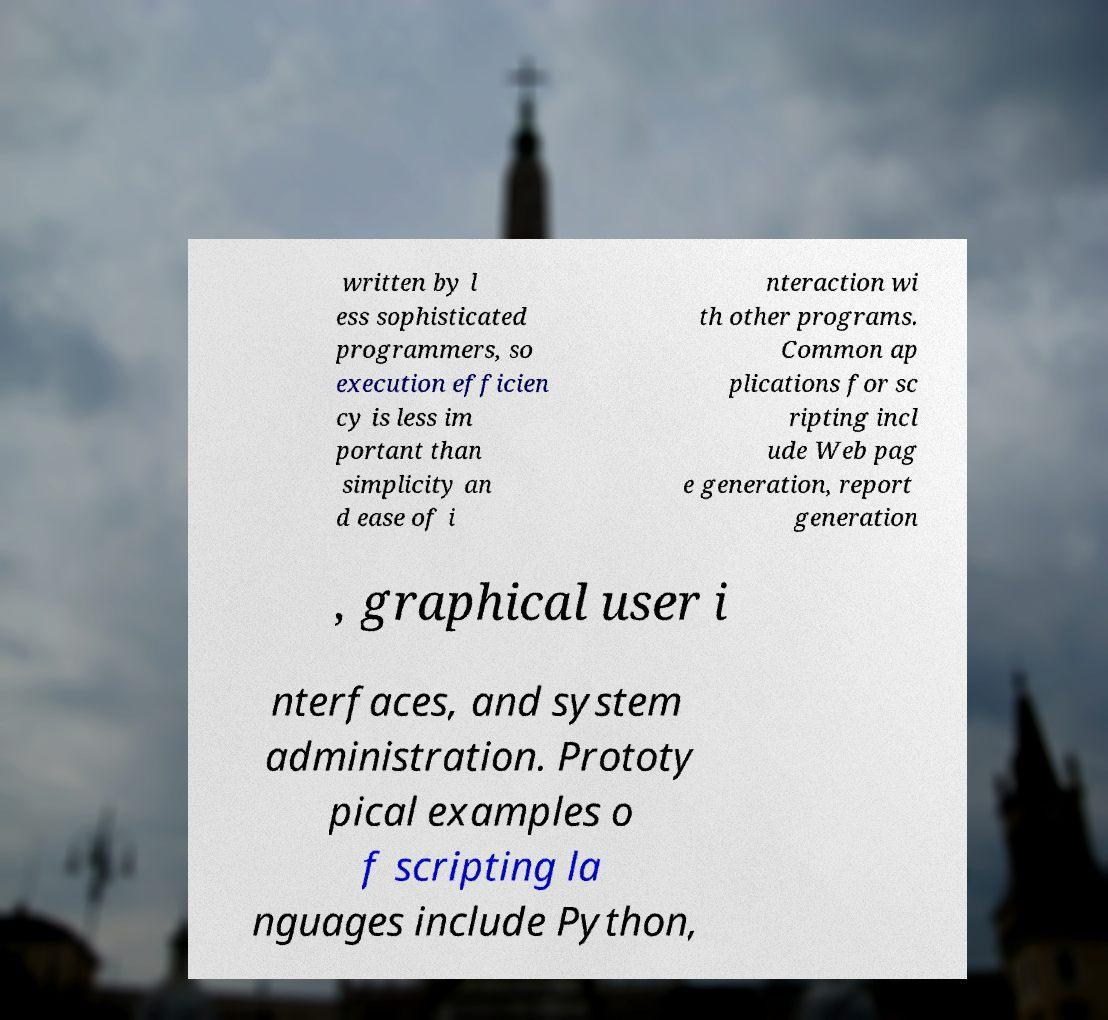Could you assist in decoding the text presented in this image and type it out clearly? written by l ess sophisticated programmers, so execution efficien cy is less im portant than simplicity an d ease of i nteraction wi th other programs. Common ap plications for sc ripting incl ude Web pag e generation, report generation , graphical user i nterfaces, and system administration. Prototy pical examples o f scripting la nguages include Python, 